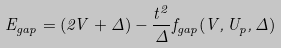<formula> <loc_0><loc_0><loc_500><loc_500>E _ { g a p } = ( 2 V + \Delta ) - \frac { t ^ { 2 } } { \Delta } f _ { g a p } ( V , U _ { p } , \Delta )</formula> 